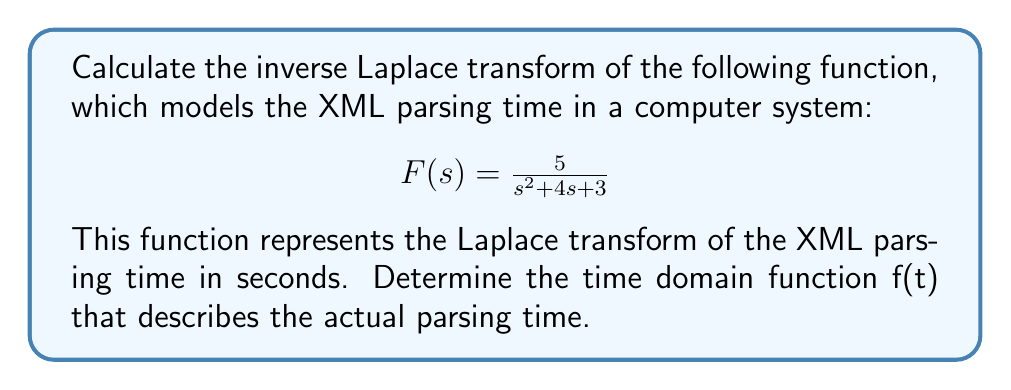Could you help me with this problem? To find the inverse Laplace transform, we'll use the method of partial fractions decomposition:

1) First, factor the denominator:
   $s^2 + 4s + 3 = (s+1)(s+3)$

2) Set up the partial fractions:
   $$\frac{5}{(s+1)(s+3)} = \frac{A}{s+1} + \frac{B}{s+3}$$

3) Find A and B:
   $5 = A(s+3) + B(s+1)$
   
   When $s = -1$: $5 = 2A$, so $A = \frac{5}{2}$
   When $s = -3$: $5 = -2B$, so $B = -\frac{5}{2}$

4) Rewrite the function:
   $$F(s) = \frac{5/2}{s+1} - \frac{5/2}{s+3}$$

5) Use the Laplace transform table to find the inverse:
   $\mathcal{L}^{-1}\{\frac{1}{s+a}\} = e^{-at}$

6) Apply the linearity property:
   $$f(t) = \frac{5}{2}e^{-t} - \frac{5}{2}e^{-3t}$$

This function represents the XML parsing time in the time domain.
Answer: $$f(t) = \frac{5}{2}e^{-t} - \frac{5}{2}e^{-3t}$$ 